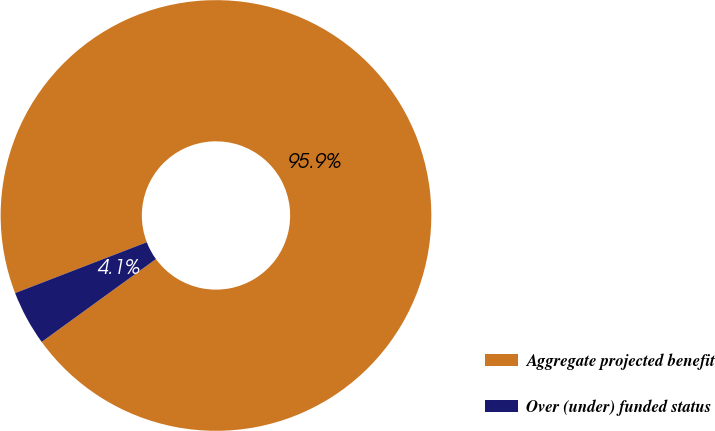Convert chart to OTSL. <chart><loc_0><loc_0><loc_500><loc_500><pie_chart><fcel>Aggregate projected benefit<fcel>Over (under) funded status<nl><fcel>95.88%<fcel>4.12%<nl></chart> 